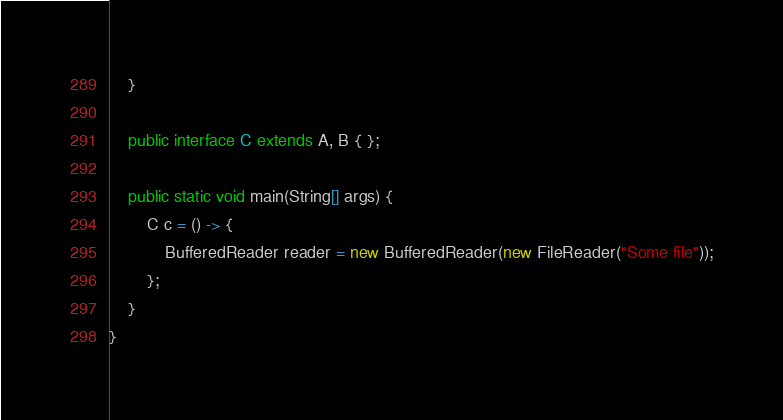<code> <loc_0><loc_0><loc_500><loc_500><_Java_>	}
	
	public interface C extends A, B { };
	
	public static void main(String[] args) {
		C c = () -> {
			BufferedReader reader = new BufferedReader(new FileReader("Some file"));
		};
    }
}
</code> 